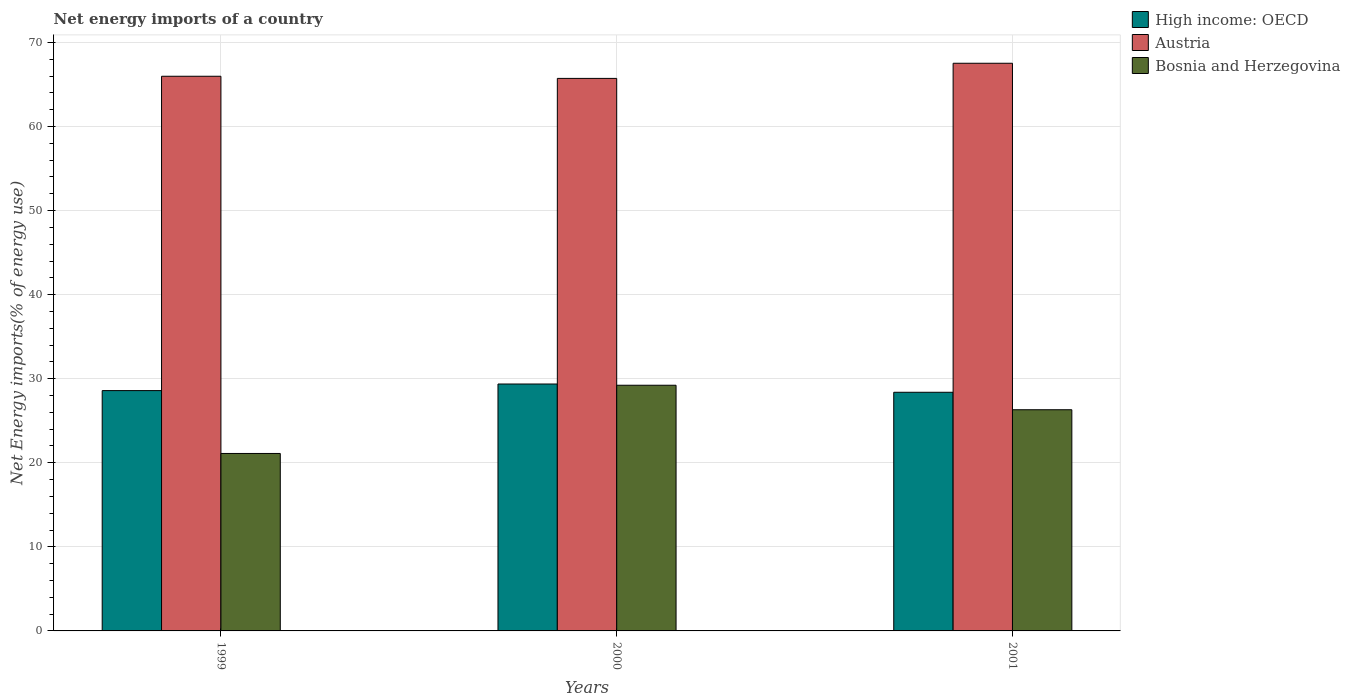How many groups of bars are there?
Give a very brief answer. 3. Are the number of bars per tick equal to the number of legend labels?
Provide a short and direct response. Yes. How many bars are there on the 1st tick from the left?
Offer a very short reply. 3. What is the net energy imports in Austria in 1999?
Offer a very short reply. 65.98. Across all years, what is the maximum net energy imports in Austria?
Offer a very short reply. 67.53. Across all years, what is the minimum net energy imports in High income: OECD?
Keep it short and to the point. 28.39. What is the total net energy imports in Bosnia and Herzegovina in the graph?
Keep it short and to the point. 76.65. What is the difference between the net energy imports in High income: OECD in 1999 and that in 2000?
Give a very brief answer. -0.78. What is the difference between the net energy imports in High income: OECD in 2000 and the net energy imports in Bosnia and Herzegovina in 1999?
Offer a very short reply. 8.26. What is the average net energy imports in High income: OECD per year?
Make the answer very short. 28.78. In the year 2000, what is the difference between the net energy imports in Austria and net energy imports in High income: OECD?
Offer a very short reply. 36.36. In how many years, is the net energy imports in Austria greater than 50 %?
Offer a very short reply. 3. What is the ratio of the net energy imports in Austria in 2000 to that in 2001?
Ensure brevity in your answer.  0.97. What is the difference between the highest and the second highest net energy imports in High income: OECD?
Keep it short and to the point. 0.78. What is the difference between the highest and the lowest net energy imports in High income: OECD?
Give a very brief answer. 0.98. What does the 2nd bar from the left in 2001 represents?
Keep it short and to the point. Austria. What does the 2nd bar from the right in 2001 represents?
Provide a short and direct response. Austria. Is it the case that in every year, the sum of the net energy imports in High income: OECD and net energy imports in Bosnia and Herzegovina is greater than the net energy imports in Austria?
Make the answer very short. No. How many bars are there?
Offer a very short reply. 9. Are all the bars in the graph horizontal?
Offer a terse response. No. How many years are there in the graph?
Offer a terse response. 3. Does the graph contain grids?
Your response must be concise. Yes. How many legend labels are there?
Offer a terse response. 3. How are the legend labels stacked?
Offer a terse response. Vertical. What is the title of the graph?
Make the answer very short. Net energy imports of a country. Does "Angola" appear as one of the legend labels in the graph?
Keep it short and to the point. No. What is the label or title of the X-axis?
Your response must be concise. Years. What is the label or title of the Y-axis?
Your response must be concise. Net Energy imports(% of energy use). What is the Net Energy imports(% of energy use) in High income: OECD in 1999?
Offer a very short reply. 28.59. What is the Net Energy imports(% of energy use) of Austria in 1999?
Your response must be concise. 65.98. What is the Net Energy imports(% of energy use) of Bosnia and Herzegovina in 1999?
Offer a terse response. 21.11. What is the Net Energy imports(% of energy use) in High income: OECD in 2000?
Your answer should be compact. 29.37. What is the Net Energy imports(% of energy use) of Austria in 2000?
Give a very brief answer. 65.73. What is the Net Energy imports(% of energy use) of Bosnia and Herzegovina in 2000?
Your answer should be very brief. 29.23. What is the Net Energy imports(% of energy use) of High income: OECD in 2001?
Keep it short and to the point. 28.39. What is the Net Energy imports(% of energy use) of Austria in 2001?
Make the answer very short. 67.53. What is the Net Energy imports(% of energy use) in Bosnia and Herzegovina in 2001?
Offer a terse response. 26.31. Across all years, what is the maximum Net Energy imports(% of energy use) of High income: OECD?
Provide a short and direct response. 29.37. Across all years, what is the maximum Net Energy imports(% of energy use) in Austria?
Make the answer very short. 67.53. Across all years, what is the maximum Net Energy imports(% of energy use) of Bosnia and Herzegovina?
Give a very brief answer. 29.23. Across all years, what is the minimum Net Energy imports(% of energy use) of High income: OECD?
Your answer should be compact. 28.39. Across all years, what is the minimum Net Energy imports(% of energy use) in Austria?
Provide a succinct answer. 65.73. Across all years, what is the minimum Net Energy imports(% of energy use) in Bosnia and Herzegovina?
Provide a succinct answer. 21.11. What is the total Net Energy imports(% of energy use) in High income: OECD in the graph?
Offer a terse response. 86.35. What is the total Net Energy imports(% of energy use) of Austria in the graph?
Provide a short and direct response. 199.24. What is the total Net Energy imports(% of energy use) in Bosnia and Herzegovina in the graph?
Your response must be concise. 76.65. What is the difference between the Net Energy imports(% of energy use) in High income: OECD in 1999 and that in 2000?
Keep it short and to the point. -0.78. What is the difference between the Net Energy imports(% of energy use) of Austria in 1999 and that in 2000?
Ensure brevity in your answer.  0.25. What is the difference between the Net Energy imports(% of energy use) in Bosnia and Herzegovina in 1999 and that in 2000?
Ensure brevity in your answer.  -8.12. What is the difference between the Net Energy imports(% of energy use) in High income: OECD in 1999 and that in 2001?
Offer a terse response. 0.2. What is the difference between the Net Energy imports(% of energy use) of Austria in 1999 and that in 2001?
Offer a very short reply. -1.55. What is the difference between the Net Energy imports(% of energy use) of Bosnia and Herzegovina in 1999 and that in 2001?
Offer a terse response. -5.2. What is the difference between the Net Energy imports(% of energy use) in High income: OECD in 2000 and that in 2001?
Ensure brevity in your answer.  0.98. What is the difference between the Net Energy imports(% of energy use) in Austria in 2000 and that in 2001?
Provide a succinct answer. -1.8. What is the difference between the Net Energy imports(% of energy use) of Bosnia and Herzegovina in 2000 and that in 2001?
Your answer should be very brief. 2.91. What is the difference between the Net Energy imports(% of energy use) of High income: OECD in 1999 and the Net Energy imports(% of energy use) of Austria in 2000?
Keep it short and to the point. -37.14. What is the difference between the Net Energy imports(% of energy use) of High income: OECD in 1999 and the Net Energy imports(% of energy use) of Bosnia and Herzegovina in 2000?
Give a very brief answer. -0.64. What is the difference between the Net Energy imports(% of energy use) of Austria in 1999 and the Net Energy imports(% of energy use) of Bosnia and Herzegovina in 2000?
Offer a very short reply. 36.76. What is the difference between the Net Energy imports(% of energy use) in High income: OECD in 1999 and the Net Energy imports(% of energy use) in Austria in 2001?
Offer a terse response. -38.94. What is the difference between the Net Energy imports(% of energy use) of High income: OECD in 1999 and the Net Energy imports(% of energy use) of Bosnia and Herzegovina in 2001?
Make the answer very short. 2.28. What is the difference between the Net Energy imports(% of energy use) in Austria in 1999 and the Net Energy imports(% of energy use) in Bosnia and Herzegovina in 2001?
Your response must be concise. 39.67. What is the difference between the Net Energy imports(% of energy use) in High income: OECD in 2000 and the Net Energy imports(% of energy use) in Austria in 2001?
Make the answer very short. -38.16. What is the difference between the Net Energy imports(% of energy use) in High income: OECD in 2000 and the Net Energy imports(% of energy use) in Bosnia and Herzegovina in 2001?
Your answer should be very brief. 3.06. What is the difference between the Net Energy imports(% of energy use) of Austria in 2000 and the Net Energy imports(% of energy use) of Bosnia and Herzegovina in 2001?
Keep it short and to the point. 39.42. What is the average Net Energy imports(% of energy use) in High income: OECD per year?
Provide a short and direct response. 28.78. What is the average Net Energy imports(% of energy use) in Austria per year?
Your response must be concise. 66.41. What is the average Net Energy imports(% of energy use) in Bosnia and Herzegovina per year?
Make the answer very short. 25.55. In the year 1999, what is the difference between the Net Energy imports(% of energy use) of High income: OECD and Net Energy imports(% of energy use) of Austria?
Your answer should be compact. -37.39. In the year 1999, what is the difference between the Net Energy imports(% of energy use) of High income: OECD and Net Energy imports(% of energy use) of Bosnia and Herzegovina?
Offer a terse response. 7.48. In the year 1999, what is the difference between the Net Energy imports(% of energy use) in Austria and Net Energy imports(% of energy use) in Bosnia and Herzegovina?
Give a very brief answer. 44.87. In the year 2000, what is the difference between the Net Energy imports(% of energy use) in High income: OECD and Net Energy imports(% of energy use) in Austria?
Keep it short and to the point. -36.36. In the year 2000, what is the difference between the Net Energy imports(% of energy use) in High income: OECD and Net Energy imports(% of energy use) in Bosnia and Herzegovina?
Give a very brief answer. 0.15. In the year 2000, what is the difference between the Net Energy imports(% of energy use) of Austria and Net Energy imports(% of energy use) of Bosnia and Herzegovina?
Offer a terse response. 36.5. In the year 2001, what is the difference between the Net Energy imports(% of energy use) of High income: OECD and Net Energy imports(% of energy use) of Austria?
Offer a very short reply. -39.14. In the year 2001, what is the difference between the Net Energy imports(% of energy use) of High income: OECD and Net Energy imports(% of energy use) of Bosnia and Herzegovina?
Make the answer very short. 2.08. In the year 2001, what is the difference between the Net Energy imports(% of energy use) in Austria and Net Energy imports(% of energy use) in Bosnia and Herzegovina?
Provide a short and direct response. 41.22. What is the ratio of the Net Energy imports(% of energy use) in High income: OECD in 1999 to that in 2000?
Make the answer very short. 0.97. What is the ratio of the Net Energy imports(% of energy use) in Bosnia and Herzegovina in 1999 to that in 2000?
Your answer should be very brief. 0.72. What is the ratio of the Net Energy imports(% of energy use) of Austria in 1999 to that in 2001?
Ensure brevity in your answer.  0.98. What is the ratio of the Net Energy imports(% of energy use) of Bosnia and Herzegovina in 1999 to that in 2001?
Your answer should be very brief. 0.8. What is the ratio of the Net Energy imports(% of energy use) in High income: OECD in 2000 to that in 2001?
Keep it short and to the point. 1.03. What is the ratio of the Net Energy imports(% of energy use) of Austria in 2000 to that in 2001?
Make the answer very short. 0.97. What is the ratio of the Net Energy imports(% of energy use) in Bosnia and Herzegovina in 2000 to that in 2001?
Your response must be concise. 1.11. What is the difference between the highest and the second highest Net Energy imports(% of energy use) in High income: OECD?
Keep it short and to the point. 0.78. What is the difference between the highest and the second highest Net Energy imports(% of energy use) of Austria?
Provide a succinct answer. 1.55. What is the difference between the highest and the second highest Net Energy imports(% of energy use) of Bosnia and Herzegovina?
Give a very brief answer. 2.91. What is the difference between the highest and the lowest Net Energy imports(% of energy use) in High income: OECD?
Provide a succinct answer. 0.98. What is the difference between the highest and the lowest Net Energy imports(% of energy use) in Austria?
Make the answer very short. 1.8. What is the difference between the highest and the lowest Net Energy imports(% of energy use) in Bosnia and Herzegovina?
Keep it short and to the point. 8.12. 